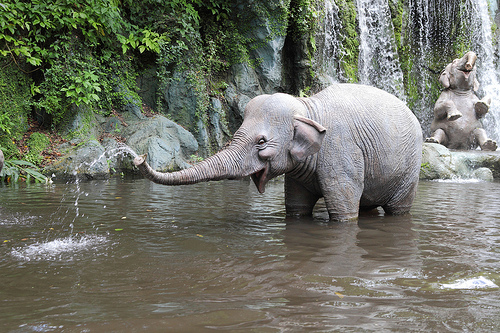Is there a tennis ball or a fence in the image? Neither a tennis ball nor a fence is present in the image. 